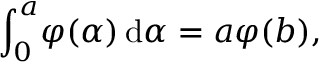Convert formula to latex. <formula><loc_0><loc_0><loc_500><loc_500>\int _ { 0 } ^ { a } \, \varphi ( \alpha ) \, \mathrm d \alpha = a \varphi ( b ) ,</formula> 